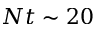Convert formula to latex. <formula><loc_0><loc_0><loc_500><loc_500>N t \sim 2 0</formula> 